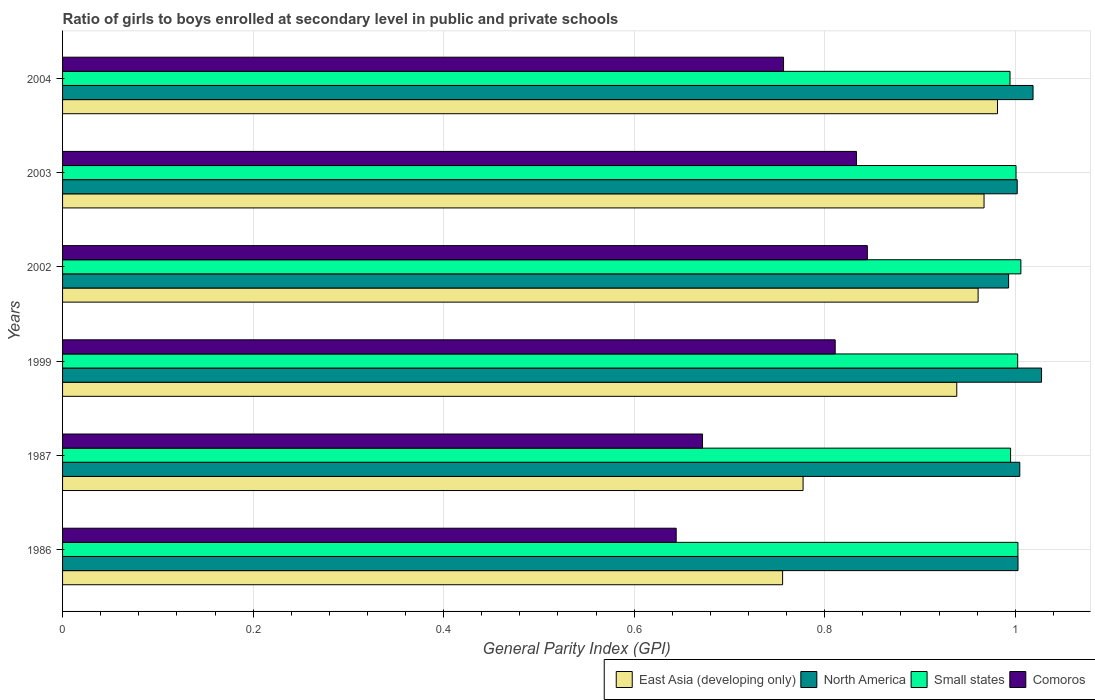How many groups of bars are there?
Offer a terse response. 6. Are the number of bars per tick equal to the number of legend labels?
Offer a terse response. Yes. What is the general parity index in East Asia (developing only) in 1999?
Your answer should be very brief. 0.94. Across all years, what is the maximum general parity index in North America?
Ensure brevity in your answer.  1.03. Across all years, what is the minimum general parity index in North America?
Your response must be concise. 0.99. In which year was the general parity index in Small states maximum?
Make the answer very short. 2002. In which year was the general parity index in Small states minimum?
Offer a terse response. 2004. What is the total general parity index in Comoros in the graph?
Provide a succinct answer. 4.56. What is the difference between the general parity index in East Asia (developing only) in 2002 and that in 2003?
Your answer should be very brief. -0.01. What is the difference between the general parity index in East Asia (developing only) in 1987 and the general parity index in North America in 1999?
Offer a terse response. -0.25. What is the average general parity index in North America per year?
Offer a terse response. 1.01. In the year 1999, what is the difference between the general parity index in Comoros and general parity index in East Asia (developing only)?
Ensure brevity in your answer.  -0.13. In how many years, is the general parity index in Comoros greater than 0.8400000000000001 ?
Provide a succinct answer. 1. What is the ratio of the general parity index in North America in 1986 to that in 1999?
Your answer should be very brief. 0.98. What is the difference between the highest and the second highest general parity index in North America?
Offer a terse response. 0.01. What is the difference between the highest and the lowest general parity index in Comoros?
Provide a short and direct response. 0.2. Is the sum of the general parity index in East Asia (developing only) in 2003 and 2004 greater than the maximum general parity index in Comoros across all years?
Your response must be concise. Yes. What does the 4th bar from the top in 2003 represents?
Make the answer very short. East Asia (developing only). What does the 1st bar from the bottom in 2002 represents?
Your response must be concise. East Asia (developing only). Is it the case that in every year, the sum of the general parity index in Small states and general parity index in North America is greater than the general parity index in East Asia (developing only)?
Give a very brief answer. Yes. How many bars are there?
Your answer should be very brief. 24. What is the difference between two consecutive major ticks on the X-axis?
Ensure brevity in your answer.  0.2. Does the graph contain any zero values?
Offer a terse response. No. What is the title of the graph?
Provide a short and direct response. Ratio of girls to boys enrolled at secondary level in public and private schools. What is the label or title of the X-axis?
Ensure brevity in your answer.  General Parity Index (GPI). What is the General Parity Index (GPI) of East Asia (developing only) in 1986?
Make the answer very short. 0.76. What is the General Parity Index (GPI) of North America in 1986?
Your answer should be very brief. 1. What is the General Parity Index (GPI) of Small states in 1986?
Make the answer very short. 1. What is the General Parity Index (GPI) of Comoros in 1986?
Your response must be concise. 0.64. What is the General Parity Index (GPI) of East Asia (developing only) in 1987?
Keep it short and to the point. 0.78. What is the General Parity Index (GPI) of North America in 1987?
Keep it short and to the point. 1. What is the General Parity Index (GPI) of Small states in 1987?
Offer a very short reply. 1. What is the General Parity Index (GPI) in Comoros in 1987?
Make the answer very short. 0.67. What is the General Parity Index (GPI) in East Asia (developing only) in 1999?
Keep it short and to the point. 0.94. What is the General Parity Index (GPI) in North America in 1999?
Offer a very short reply. 1.03. What is the General Parity Index (GPI) in Small states in 1999?
Provide a succinct answer. 1. What is the General Parity Index (GPI) of Comoros in 1999?
Offer a very short reply. 0.81. What is the General Parity Index (GPI) in East Asia (developing only) in 2002?
Offer a very short reply. 0.96. What is the General Parity Index (GPI) in North America in 2002?
Provide a short and direct response. 0.99. What is the General Parity Index (GPI) in Small states in 2002?
Give a very brief answer. 1.01. What is the General Parity Index (GPI) of Comoros in 2002?
Provide a succinct answer. 0.84. What is the General Parity Index (GPI) of East Asia (developing only) in 2003?
Offer a very short reply. 0.97. What is the General Parity Index (GPI) in North America in 2003?
Your response must be concise. 1. What is the General Parity Index (GPI) of Small states in 2003?
Provide a short and direct response. 1. What is the General Parity Index (GPI) in Comoros in 2003?
Provide a succinct answer. 0.83. What is the General Parity Index (GPI) in East Asia (developing only) in 2004?
Offer a very short reply. 0.98. What is the General Parity Index (GPI) in North America in 2004?
Offer a very short reply. 1.02. What is the General Parity Index (GPI) of Small states in 2004?
Ensure brevity in your answer.  0.99. What is the General Parity Index (GPI) in Comoros in 2004?
Provide a short and direct response. 0.76. Across all years, what is the maximum General Parity Index (GPI) in East Asia (developing only)?
Your answer should be compact. 0.98. Across all years, what is the maximum General Parity Index (GPI) in North America?
Give a very brief answer. 1.03. Across all years, what is the maximum General Parity Index (GPI) in Small states?
Keep it short and to the point. 1.01. Across all years, what is the maximum General Parity Index (GPI) in Comoros?
Your answer should be compact. 0.84. Across all years, what is the minimum General Parity Index (GPI) in East Asia (developing only)?
Provide a succinct answer. 0.76. Across all years, what is the minimum General Parity Index (GPI) of North America?
Your answer should be compact. 0.99. Across all years, what is the minimum General Parity Index (GPI) of Small states?
Give a very brief answer. 0.99. Across all years, what is the minimum General Parity Index (GPI) in Comoros?
Make the answer very short. 0.64. What is the total General Parity Index (GPI) of East Asia (developing only) in the graph?
Give a very brief answer. 5.38. What is the total General Parity Index (GPI) in North America in the graph?
Your response must be concise. 6.05. What is the total General Parity Index (GPI) of Small states in the graph?
Your response must be concise. 6. What is the total General Parity Index (GPI) in Comoros in the graph?
Give a very brief answer. 4.56. What is the difference between the General Parity Index (GPI) of East Asia (developing only) in 1986 and that in 1987?
Offer a very short reply. -0.02. What is the difference between the General Parity Index (GPI) in North America in 1986 and that in 1987?
Provide a succinct answer. -0. What is the difference between the General Parity Index (GPI) of Small states in 1986 and that in 1987?
Provide a succinct answer. 0.01. What is the difference between the General Parity Index (GPI) in Comoros in 1986 and that in 1987?
Ensure brevity in your answer.  -0.03. What is the difference between the General Parity Index (GPI) in East Asia (developing only) in 1986 and that in 1999?
Provide a short and direct response. -0.18. What is the difference between the General Parity Index (GPI) of North America in 1986 and that in 1999?
Ensure brevity in your answer.  -0.02. What is the difference between the General Parity Index (GPI) in Small states in 1986 and that in 1999?
Ensure brevity in your answer.  0. What is the difference between the General Parity Index (GPI) of Comoros in 1986 and that in 1999?
Keep it short and to the point. -0.17. What is the difference between the General Parity Index (GPI) in East Asia (developing only) in 1986 and that in 2002?
Your answer should be very brief. -0.21. What is the difference between the General Parity Index (GPI) in North America in 1986 and that in 2002?
Keep it short and to the point. 0.01. What is the difference between the General Parity Index (GPI) of Small states in 1986 and that in 2002?
Give a very brief answer. -0. What is the difference between the General Parity Index (GPI) of Comoros in 1986 and that in 2002?
Your answer should be compact. -0.2. What is the difference between the General Parity Index (GPI) of East Asia (developing only) in 1986 and that in 2003?
Offer a very short reply. -0.21. What is the difference between the General Parity Index (GPI) in North America in 1986 and that in 2003?
Give a very brief answer. 0. What is the difference between the General Parity Index (GPI) in Small states in 1986 and that in 2003?
Provide a succinct answer. 0. What is the difference between the General Parity Index (GPI) in Comoros in 1986 and that in 2003?
Provide a succinct answer. -0.19. What is the difference between the General Parity Index (GPI) in East Asia (developing only) in 1986 and that in 2004?
Keep it short and to the point. -0.23. What is the difference between the General Parity Index (GPI) in North America in 1986 and that in 2004?
Provide a short and direct response. -0.02. What is the difference between the General Parity Index (GPI) of Small states in 1986 and that in 2004?
Offer a terse response. 0.01. What is the difference between the General Parity Index (GPI) of Comoros in 1986 and that in 2004?
Offer a terse response. -0.11. What is the difference between the General Parity Index (GPI) in East Asia (developing only) in 1987 and that in 1999?
Your response must be concise. -0.16. What is the difference between the General Parity Index (GPI) in North America in 1987 and that in 1999?
Make the answer very short. -0.02. What is the difference between the General Parity Index (GPI) in Small states in 1987 and that in 1999?
Provide a short and direct response. -0.01. What is the difference between the General Parity Index (GPI) in Comoros in 1987 and that in 1999?
Provide a short and direct response. -0.14. What is the difference between the General Parity Index (GPI) in East Asia (developing only) in 1987 and that in 2002?
Your answer should be compact. -0.18. What is the difference between the General Parity Index (GPI) of North America in 1987 and that in 2002?
Give a very brief answer. 0.01. What is the difference between the General Parity Index (GPI) of Small states in 1987 and that in 2002?
Your answer should be very brief. -0.01. What is the difference between the General Parity Index (GPI) of Comoros in 1987 and that in 2002?
Offer a very short reply. -0.17. What is the difference between the General Parity Index (GPI) of East Asia (developing only) in 1987 and that in 2003?
Make the answer very short. -0.19. What is the difference between the General Parity Index (GPI) of North America in 1987 and that in 2003?
Keep it short and to the point. 0. What is the difference between the General Parity Index (GPI) in Small states in 1987 and that in 2003?
Your answer should be very brief. -0.01. What is the difference between the General Parity Index (GPI) in Comoros in 1987 and that in 2003?
Your answer should be compact. -0.16. What is the difference between the General Parity Index (GPI) in East Asia (developing only) in 1987 and that in 2004?
Your answer should be compact. -0.2. What is the difference between the General Parity Index (GPI) in North America in 1987 and that in 2004?
Give a very brief answer. -0.01. What is the difference between the General Parity Index (GPI) of Small states in 1987 and that in 2004?
Offer a terse response. 0. What is the difference between the General Parity Index (GPI) in Comoros in 1987 and that in 2004?
Keep it short and to the point. -0.09. What is the difference between the General Parity Index (GPI) of East Asia (developing only) in 1999 and that in 2002?
Provide a short and direct response. -0.02. What is the difference between the General Parity Index (GPI) in North America in 1999 and that in 2002?
Provide a short and direct response. 0.03. What is the difference between the General Parity Index (GPI) of Small states in 1999 and that in 2002?
Keep it short and to the point. -0. What is the difference between the General Parity Index (GPI) of Comoros in 1999 and that in 2002?
Your response must be concise. -0.03. What is the difference between the General Parity Index (GPI) of East Asia (developing only) in 1999 and that in 2003?
Your answer should be compact. -0.03. What is the difference between the General Parity Index (GPI) in North America in 1999 and that in 2003?
Make the answer very short. 0.03. What is the difference between the General Parity Index (GPI) in Small states in 1999 and that in 2003?
Offer a terse response. 0. What is the difference between the General Parity Index (GPI) in Comoros in 1999 and that in 2003?
Keep it short and to the point. -0.02. What is the difference between the General Parity Index (GPI) in East Asia (developing only) in 1999 and that in 2004?
Offer a terse response. -0.04. What is the difference between the General Parity Index (GPI) in North America in 1999 and that in 2004?
Provide a short and direct response. 0.01. What is the difference between the General Parity Index (GPI) in Small states in 1999 and that in 2004?
Provide a short and direct response. 0.01. What is the difference between the General Parity Index (GPI) in Comoros in 1999 and that in 2004?
Your answer should be compact. 0.05. What is the difference between the General Parity Index (GPI) in East Asia (developing only) in 2002 and that in 2003?
Give a very brief answer. -0.01. What is the difference between the General Parity Index (GPI) in North America in 2002 and that in 2003?
Make the answer very short. -0.01. What is the difference between the General Parity Index (GPI) in Small states in 2002 and that in 2003?
Offer a terse response. 0.01. What is the difference between the General Parity Index (GPI) in Comoros in 2002 and that in 2003?
Ensure brevity in your answer.  0.01. What is the difference between the General Parity Index (GPI) of East Asia (developing only) in 2002 and that in 2004?
Provide a short and direct response. -0.02. What is the difference between the General Parity Index (GPI) in North America in 2002 and that in 2004?
Give a very brief answer. -0.03. What is the difference between the General Parity Index (GPI) of Small states in 2002 and that in 2004?
Keep it short and to the point. 0.01. What is the difference between the General Parity Index (GPI) of Comoros in 2002 and that in 2004?
Ensure brevity in your answer.  0.09. What is the difference between the General Parity Index (GPI) of East Asia (developing only) in 2003 and that in 2004?
Make the answer very short. -0.01. What is the difference between the General Parity Index (GPI) of North America in 2003 and that in 2004?
Keep it short and to the point. -0.02. What is the difference between the General Parity Index (GPI) of Small states in 2003 and that in 2004?
Offer a terse response. 0.01. What is the difference between the General Parity Index (GPI) of Comoros in 2003 and that in 2004?
Your answer should be very brief. 0.08. What is the difference between the General Parity Index (GPI) of East Asia (developing only) in 1986 and the General Parity Index (GPI) of North America in 1987?
Give a very brief answer. -0.25. What is the difference between the General Parity Index (GPI) of East Asia (developing only) in 1986 and the General Parity Index (GPI) of Small states in 1987?
Offer a very short reply. -0.24. What is the difference between the General Parity Index (GPI) in East Asia (developing only) in 1986 and the General Parity Index (GPI) in Comoros in 1987?
Ensure brevity in your answer.  0.08. What is the difference between the General Parity Index (GPI) in North America in 1986 and the General Parity Index (GPI) in Small states in 1987?
Make the answer very short. 0.01. What is the difference between the General Parity Index (GPI) of North America in 1986 and the General Parity Index (GPI) of Comoros in 1987?
Provide a succinct answer. 0.33. What is the difference between the General Parity Index (GPI) of Small states in 1986 and the General Parity Index (GPI) of Comoros in 1987?
Ensure brevity in your answer.  0.33. What is the difference between the General Parity Index (GPI) of East Asia (developing only) in 1986 and the General Parity Index (GPI) of North America in 1999?
Your response must be concise. -0.27. What is the difference between the General Parity Index (GPI) of East Asia (developing only) in 1986 and the General Parity Index (GPI) of Small states in 1999?
Make the answer very short. -0.25. What is the difference between the General Parity Index (GPI) of East Asia (developing only) in 1986 and the General Parity Index (GPI) of Comoros in 1999?
Your response must be concise. -0.06. What is the difference between the General Parity Index (GPI) in North America in 1986 and the General Parity Index (GPI) in Comoros in 1999?
Offer a terse response. 0.19. What is the difference between the General Parity Index (GPI) of Small states in 1986 and the General Parity Index (GPI) of Comoros in 1999?
Keep it short and to the point. 0.19. What is the difference between the General Parity Index (GPI) in East Asia (developing only) in 1986 and the General Parity Index (GPI) in North America in 2002?
Keep it short and to the point. -0.24. What is the difference between the General Parity Index (GPI) in East Asia (developing only) in 1986 and the General Parity Index (GPI) in Small states in 2002?
Your answer should be very brief. -0.25. What is the difference between the General Parity Index (GPI) in East Asia (developing only) in 1986 and the General Parity Index (GPI) in Comoros in 2002?
Your answer should be compact. -0.09. What is the difference between the General Parity Index (GPI) in North America in 1986 and the General Parity Index (GPI) in Small states in 2002?
Provide a succinct answer. -0. What is the difference between the General Parity Index (GPI) of North America in 1986 and the General Parity Index (GPI) of Comoros in 2002?
Your answer should be compact. 0.16. What is the difference between the General Parity Index (GPI) in Small states in 1986 and the General Parity Index (GPI) in Comoros in 2002?
Your response must be concise. 0.16. What is the difference between the General Parity Index (GPI) of East Asia (developing only) in 1986 and the General Parity Index (GPI) of North America in 2003?
Offer a very short reply. -0.25. What is the difference between the General Parity Index (GPI) of East Asia (developing only) in 1986 and the General Parity Index (GPI) of Small states in 2003?
Keep it short and to the point. -0.24. What is the difference between the General Parity Index (GPI) in East Asia (developing only) in 1986 and the General Parity Index (GPI) in Comoros in 2003?
Your response must be concise. -0.08. What is the difference between the General Parity Index (GPI) in North America in 1986 and the General Parity Index (GPI) in Small states in 2003?
Provide a succinct answer. 0. What is the difference between the General Parity Index (GPI) in North America in 1986 and the General Parity Index (GPI) in Comoros in 2003?
Make the answer very short. 0.17. What is the difference between the General Parity Index (GPI) in Small states in 1986 and the General Parity Index (GPI) in Comoros in 2003?
Your answer should be compact. 0.17. What is the difference between the General Parity Index (GPI) of East Asia (developing only) in 1986 and the General Parity Index (GPI) of North America in 2004?
Your answer should be compact. -0.26. What is the difference between the General Parity Index (GPI) of East Asia (developing only) in 1986 and the General Parity Index (GPI) of Small states in 2004?
Your answer should be very brief. -0.24. What is the difference between the General Parity Index (GPI) of East Asia (developing only) in 1986 and the General Parity Index (GPI) of Comoros in 2004?
Ensure brevity in your answer.  -0. What is the difference between the General Parity Index (GPI) of North America in 1986 and the General Parity Index (GPI) of Small states in 2004?
Provide a short and direct response. 0.01. What is the difference between the General Parity Index (GPI) of North America in 1986 and the General Parity Index (GPI) of Comoros in 2004?
Your response must be concise. 0.25. What is the difference between the General Parity Index (GPI) of Small states in 1986 and the General Parity Index (GPI) of Comoros in 2004?
Make the answer very short. 0.25. What is the difference between the General Parity Index (GPI) in East Asia (developing only) in 1987 and the General Parity Index (GPI) in North America in 1999?
Offer a very short reply. -0.25. What is the difference between the General Parity Index (GPI) in East Asia (developing only) in 1987 and the General Parity Index (GPI) in Small states in 1999?
Offer a very short reply. -0.23. What is the difference between the General Parity Index (GPI) of East Asia (developing only) in 1987 and the General Parity Index (GPI) of Comoros in 1999?
Give a very brief answer. -0.03. What is the difference between the General Parity Index (GPI) of North America in 1987 and the General Parity Index (GPI) of Small states in 1999?
Provide a succinct answer. 0. What is the difference between the General Parity Index (GPI) of North America in 1987 and the General Parity Index (GPI) of Comoros in 1999?
Make the answer very short. 0.19. What is the difference between the General Parity Index (GPI) in Small states in 1987 and the General Parity Index (GPI) in Comoros in 1999?
Provide a short and direct response. 0.18. What is the difference between the General Parity Index (GPI) in East Asia (developing only) in 1987 and the General Parity Index (GPI) in North America in 2002?
Offer a terse response. -0.22. What is the difference between the General Parity Index (GPI) in East Asia (developing only) in 1987 and the General Parity Index (GPI) in Small states in 2002?
Provide a short and direct response. -0.23. What is the difference between the General Parity Index (GPI) of East Asia (developing only) in 1987 and the General Parity Index (GPI) of Comoros in 2002?
Offer a terse response. -0.07. What is the difference between the General Parity Index (GPI) of North America in 1987 and the General Parity Index (GPI) of Small states in 2002?
Offer a terse response. -0. What is the difference between the General Parity Index (GPI) of North America in 1987 and the General Parity Index (GPI) of Comoros in 2002?
Your answer should be very brief. 0.16. What is the difference between the General Parity Index (GPI) in Small states in 1987 and the General Parity Index (GPI) in Comoros in 2002?
Offer a terse response. 0.15. What is the difference between the General Parity Index (GPI) of East Asia (developing only) in 1987 and the General Parity Index (GPI) of North America in 2003?
Your answer should be very brief. -0.22. What is the difference between the General Parity Index (GPI) of East Asia (developing only) in 1987 and the General Parity Index (GPI) of Small states in 2003?
Your response must be concise. -0.22. What is the difference between the General Parity Index (GPI) of East Asia (developing only) in 1987 and the General Parity Index (GPI) of Comoros in 2003?
Make the answer very short. -0.06. What is the difference between the General Parity Index (GPI) of North America in 1987 and the General Parity Index (GPI) of Small states in 2003?
Keep it short and to the point. 0. What is the difference between the General Parity Index (GPI) of North America in 1987 and the General Parity Index (GPI) of Comoros in 2003?
Offer a very short reply. 0.17. What is the difference between the General Parity Index (GPI) of Small states in 1987 and the General Parity Index (GPI) of Comoros in 2003?
Offer a terse response. 0.16. What is the difference between the General Parity Index (GPI) of East Asia (developing only) in 1987 and the General Parity Index (GPI) of North America in 2004?
Give a very brief answer. -0.24. What is the difference between the General Parity Index (GPI) in East Asia (developing only) in 1987 and the General Parity Index (GPI) in Small states in 2004?
Provide a short and direct response. -0.22. What is the difference between the General Parity Index (GPI) in East Asia (developing only) in 1987 and the General Parity Index (GPI) in Comoros in 2004?
Your answer should be compact. 0.02. What is the difference between the General Parity Index (GPI) of North America in 1987 and the General Parity Index (GPI) of Small states in 2004?
Provide a succinct answer. 0.01. What is the difference between the General Parity Index (GPI) in North America in 1987 and the General Parity Index (GPI) in Comoros in 2004?
Keep it short and to the point. 0.25. What is the difference between the General Parity Index (GPI) of Small states in 1987 and the General Parity Index (GPI) of Comoros in 2004?
Provide a short and direct response. 0.24. What is the difference between the General Parity Index (GPI) in East Asia (developing only) in 1999 and the General Parity Index (GPI) in North America in 2002?
Ensure brevity in your answer.  -0.05. What is the difference between the General Parity Index (GPI) in East Asia (developing only) in 1999 and the General Parity Index (GPI) in Small states in 2002?
Provide a succinct answer. -0.07. What is the difference between the General Parity Index (GPI) in East Asia (developing only) in 1999 and the General Parity Index (GPI) in Comoros in 2002?
Your answer should be very brief. 0.09. What is the difference between the General Parity Index (GPI) in North America in 1999 and the General Parity Index (GPI) in Small states in 2002?
Provide a succinct answer. 0.02. What is the difference between the General Parity Index (GPI) of North America in 1999 and the General Parity Index (GPI) of Comoros in 2002?
Your answer should be compact. 0.18. What is the difference between the General Parity Index (GPI) in Small states in 1999 and the General Parity Index (GPI) in Comoros in 2002?
Provide a short and direct response. 0.16. What is the difference between the General Parity Index (GPI) of East Asia (developing only) in 1999 and the General Parity Index (GPI) of North America in 2003?
Make the answer very short. -0.06. What is the difference between the General Parity Index (GPI) in East Asia (developing only) in 1999 and the General Parity Index (GPI) in Small states in 2003?
Provide a succinct answer. -0.06. What is the difference between the General Parity Index (GPI) of East Asia (developing only) in 1999 and the General Parity Index (GPI) of Comoros in 2003?
Provide a short and direct response. 0.11. What is the difference between the General Parity Index (GPI) in North America in 1999 and the General Parity Index (GPI) in Small states in 2003?
Your answer should be compact. 0.03. What is the difference between the General Parity Index (GPI) in North America in 1999 and the General Parity Index (GPI) in Comoros in 2003?
Your response must be concise. 0.19. What is the difference between the General Parity Index (GPI) in Small states in 1999 and the General Parity Index (GPI) in Comoros in 2003?
Your answer should be compact. 0.17. What is the difference between the General Parity Index (GPI) in East Asia (developing only) in 1999 and the General Parity Index (GPI) in North America in 2004?
Ensure brevity in your answer.  -0.08. What is the difference between the General Parity Index (GPI) in East Asia (developing only) in 1999 and the General Parity Index (GPI) in Small states in 2004?
Ensure brevity in your answer.  -0.06. What is the difference between the General Parity Index (GPI) of East Asia (developing only) in 1999 and the General Parity Index (GPI) of Comoros in 2004?
Your response must be concise. 0.18. What is the difference between the General Parity Index (GPI) in North America in 1999 and the General Parity Index (GPI) in Small states in 2004?
Your answer should be very brief. 0.03. What is the difference between the General Parity Index (GPI) in North America in 1999 and the General Parity Index (GPI) in Comoros in 2004?
Ensure brevity in your answer.  0.27. What is the difference between the General Parity Index (GPI) in Small states in 1999 and the General Parity Index (GPI) in Comoros in 2004?
Keep it short and to the point. 0.25. What is the difference between the General Parity Index (GPI) in East Asia (developing only) in 2002 and the General Parity Index (GPI) in North America in 2003?
Your answer should be compact. -0.04. What is the difference between the General Parity Index (GPI) in East Asia (developing only) in 2002 and the General Parity Index (GPI) in Small states in 2003?
Provide a succinct answer. -0.04. What is the difference between the General Parity Index (GPI) in East Asia (developing only) in 2002 and the General Parity Index (GPI) in Comoros in 2003?
Give a very brief answer. 0.13. What is the difference between the General Parity Index (GPI) in North America in 2002 and the General Parity Index (GPI) in Small states in 2003?
Your answer should be very brief. -0.01. What is the difference between the General Parity Index (GPI) in North America in 2002 and the General Parity Index (GPI) in Comoros in 2003?
Offer a terse response. 0.16. What is the difference between the General Parity Index (GPI) of Small states in 2002 and the General Parity Index (GPI) of Comoros in 2003?
Your answer should be very brief. 0.17. What is the difference between the General Parity Index (GPI) in East Asia (developing only) in 2002 and the General Parity Index (GPI) in North America in 2004?
Keep it short and to the point. -0.06. What is the difference between the General Parity Index (GPI) in East Asia (developing only) in 2002 and the General Parity Index (GPI) in Small states in 2004?
Offer a terse response. -0.03. What is the difference between the General Parity Index (GPI) of East Asia (developing only) in 2002 and the General Parity Index (GPI) of Comoros in 2004?
Provide a succinct answer. 0.2. What is the difference between the General Parity Index (GPI) in North America in 2002 and the General Parity Index (GPI) in Small states in 2004?
Provide a short and direct response. -0. What is the difference between the General Parity Index (GPI) of North America in 2002 and the General Parity Index (GPI) of Comoros in 2004?
Give a very brief answer. 0.24. What is the difference between the General Parity Index (GPI) in Small states in 2002 and the General Parity Index (GPI) in Comoros in 2004?
Provide a short and direct response. 0.25. What is the difference between the General Parity Index (GPI) of East Asia (developing only) in 2003 and the General Parity Index (GPI) of North America in 2004?
Ensure brevity in your answer.  -0.05. What is the difference between the General Parity Index (GPI) in East Asia (developing only) in 2003 and the General Parity Index (GPI) in Small states in 2004?
Your answer should be very brief. -0.03. What is the difference between the General Parity Index (GPI) in East Asia (developing only) in 2003 and the General Parity Index (GPI) in Comoros in 2004?
Ensure brevity in your answer.  0.21. What is the difference between the General Parity Index (GPI) in North America in 2003 and the General Parity Index (GPI) in Small states in 2004?
Make the answer very short. 0.01. What is the difference between the General Parity Index (GPI) of North America in 2003 and the General Parity Index (GPI) of Comoros in 2004?
Provide a succinct answer. 0.25. What is the difference between the General Parity Index (GPI) in Small states in 2003 and the General Parity Index (GPI) in Comoros in 2004?
Offer a terse response. 0.24. What is the average General Parity Index (GPI) of East Asia (developing only) per year?
Offer a very short reply. 0.9. What is the average General Parity Index (GPI) in Comoros per year?
Your response must be concise. 0.76. In the year 1986, what is the difference between the General Parity Index (GPI) of East Asia (developing only) and General Parity Index (GPI) of North America?
Provide a succinct answer. -0.25. In the year 1986, what is the difference between the General Parity Index (GPI) of East Asia (developing only) and General Parity Index (GPI) of Small states?
Your answer should be compact. -0.25. In the year 1986, what is the difference between the General Parity Index (GPI) of East Asia (developing only) and General Parity Index (GPI) of Comoros?
Offer a very short reply. 0.11. In the year 1986, what is the difference between the General Parity Index (GPI) of North America and General Parity Index (GPI) of Comoros?
Your answer should be compact. 0.36. In the year 1986, what is the difference between the General Parity Index (GPI) in Small states and General Parity Index (GPI) in Comoros?
Your answer should be compact. 0.36. In the year 1987, what is the difference between the General Parity Index (GPI) of East Asia (developing only) and General Parity Index (GPI) of North America?
Offer a terse response. -0.23. In the year 1987, what is the difference between the General Parity Index (GPI) of East Asia (developing only) and General Parity Index (GPI) of Small states?
Keep it short and to the point. -0.22. In the year 1987, what is the difference between the General Parity Index (GPI) of East Asia (developing only) and General Parity Index (GPI) of Comoros?
Provide a short and direct response. 0.11. In the year 1987, what is the difference between the General Parity Index (GPI) in North America and General Parity Index (GPI) in Small states?
Make the answer very short. 0.01. In the year 1987, what is the difference between the General Parity Index (GPI) of North America and General Parity Index (GPI) of Comoros?
Your answer should be compact. 0.33. In the year 1987, what is the difference between the General Parity Index (GPI) in Small states and General Parity Index (GPI) in Comoros?
Offer a terse response. 0.32. In the year 1999, what is the difference between the General Parity Index (GPI) of East Asia (developing only) and General Parity Index (GPI) of North America?
Make the answer very short. -0.09. In the year 1999, what is the difference between the General Parity Index (GPI) of East Asia (developing only) and General Parity Index (GPI) of Small states?
Keep it short and to the point. -0.06. In the year 1999, what is the difference between the General Parity Index (GPI) of East Asia (developing only) and General Parity Index (GPI) of Comoros?
Provide a succinct answer. 0.13. In the year 1999, what is the difference between the General Parity Index (GPI) in North America and General Parity Index (GPI) in Small states?
Your answer should be very brief. 0.03. In the year 1999, what is the difference between the General Parity Index (GPI) of North America and General Parity Index (GPI) of Comoros?
Ensure brevity in your answer.  0.22. In the year 1999, what is the difference between the General Parity Index (GPI) in Small states and General Parity Index (GPI) in Comoros?
Ensure brevity in your answer.  0.19. In the year 2002, what is the difference between the General Parity Index (GPI) in East Asia (developing only) and General Parity Index (GPI) in North America?
Your answer should be very brief. -0.03. In the year 2002, what is the difference between the General Parity Index (GPI) of East Asia (developing only) and General Parity Index (GPI) of Small states?
Make the answer very short. -0.04. In the year 2002, what is the difference between the General Parity Index (GPI) in East Asia (developing only) and General Parity Index (GPI) in Comoros?
Provide a succinct answer. 0.12. In the year 2002, what is the difference between the General Parity Index (GPI) of North America and General Parity Index (GPI) of Small states?
Provide a succinct answer. -0.01. In the year 2002, what is the difference between the General Parity Index (GPI) in North America and General Parity Index (GPI) in Comoros?
Give a very brief answer. 0.15. In the year 2002, what is the difference between the General Parity Index (GPI) of Small states and General Parity Index (GPI) of Comoros?
Ensure brevity in your answer.  0.16. In the year 2003, what is the difference between the General Parity Index (GPI) of East Asia (developing only) and General Parity Index (GPI) of North America?
Provide a short and direct response. -0.03. In the year 2003, what is the difference between the General Parity Index (GPI) in East Asia (developing only) and General Parity Index (GPI) in Small states?
Your answer should be compact. -0.03. In the year 2003, what is the difference between the General Parity Index (GPI) of East Asia (developing only) and General Parity Index (GPI) of Comoros?
Offer a very short reply. 0.13. In the year 2003, what is the difference between the General Parity Index (GPI) of North America and General Parity Index (GPI) of Small states?
Provide a short and direct response. 0. In the year 2003, what is the difference between the General Parity Index (GPI) of North America and General Parity Index (GPI) of Comoros?
Your answer should be compact. 0.17. In the year 2003, what is the difference between the General Parity Index (GPI) in Small states and General Parity Index (GPI) in Comoros?
Offer a very short reply. 0.17. In the year 2004, what is the difference between the General Parity Index (GPI) of East Asia (developing only) and General Parity Index (GPI) of North America?
Ensure brevity in your answer.  -0.04. In the year 2004, what is the difference between the General Parity Index (GPI) of East Asia (developing only) and General Parity Index (GPI) of Small states?
Your answer should be very brief. -0.01. In the year 2004, what is the difference between the General Parity Index (GPI) of East Asia (developing only) and General Parity Index (GPI) of Comoros?
Give a very brief answer. 0.22. In the year 2004, what is the difference between the General Parity Index (GPI) of North America and General Parity Index (GPI) of Small states?
Ensure brevity in your answer.  0.02. In the year 2004, what is the difference between the General Parity Index (GPI) in North America and General Parity Index (GPI) in Comoros?
Your answer should be very brief. 0.26. In the year 2004, what is the difference between the General Parity Index (GPI) in Small states and General Parity Index (GPI) in Comoros?
Ensure brevity in your answer.  0.24. What is the ratio of the General Parity Index (GPI) in East Asia (developing only) in 1986 to that in 1987?
Your response must be concise. 0.97. What is the ratio of the General Parity Index (GPI) of Small states in 1986 to that in 1987?
Your response must be concise. 1.01. What is the ratio of the General Parity Index (GPI) in Comoros in 1986 to that in 1987?
Your answer should be compact. 0.96. What is the ratio of the General Parity Index (GPI) in East Asia (developing only) in 1986 to that in 1999?
Make the answer very short. 0.81. What is the ratio of the General Parity Index (GPI) of North America in 1986 to that in 1999?
Provide a short and direct response. 0.98. What is the ratio of the General Parity Index (GPI) in Comoros in 1986 to that in 1999?
Ensure brevity in your answer.  0.79. What is the ratio of the General Parity Index (GPI) in East Asia (developing only) in 1986 to that in 2002?
Offer a very short reply. 0.79. What is the ratio of the General Parity Index (GPI) of North America in 1986 to that in 2002?
Offer a terse response. 1.01. What is the ratio of the General Parity Index (GPI) of Small states in 1986 to that in 2002?
Provide a short and direct response. 1. What is the ratio of the General Parity Index (GPI) in Comoros in 1986 to that in 2002?
Your answer should be compact. 0.76. What is the ratio of the General Parity Index (GPI) of East Asia (developing only) in 1986 to that in 2003?
Provide a short and direct response. 0.78. What is the ratio of the General Parity Index (GPI) in North America in 1986 to that in 2003?
Ensure brevity in your answer.  1. What is the ratio of the General Parity Index (GPI) in Small states in 1986 to that in 2003?
Provide a short and direct response. 1. What is the ratio of the General Parity Index (GPI) in Comoros in 1986 to that in 2003?
Provide a succinct answer. 0.77. What is the ratio of the General Parity Index (GPI) in East Asia (developing only) in 1986 to that in 2004?
Make the answer very short. 0.77. What is the ratio of the General Parity Index (GPI) of North America in 1986 to that in 2004?
Your response must be concise. 0.98. What is the ratio of the General Parity Index (GPI) in Small states in 1986 to that in 2004?
Provide a succinct answer. 1.01. What is the ratio of the General Parity Index (GPI) in Comoros in 1986 to that in 2004?
Provide a succinct answer. 0.85. What is the ratio of the General Parity Index (GPI) in East Asia (developing only) in 1987 to that in 1999?
Make the answer very short. 0.83. What is the ratio of the General Parity Index (GPI) of North America in 1987 to that in 1999?
Provide a short and direct response. 0.98. What is the ratio of the General Parity Index (GPI) in Small states in 1987 to that in 1999?
Offer a very short reply. 0.99. What is the ratio of the General Parity Index (GPI) of Comoros in 1987 to that in 1999?
Provide a succinct answer. 0.83. What is the ratio of the General Parity Index (GPI) in East Asia (developing only) in 1987 to that in 2002?
Offer a terse response. 0.81. What is the ratio of the General Parity Index (GPI) of North America in 1987 to that in 2002?
Provide a succinct answer. 1.01. What is the ratio of the General Parity Index (GPI) in Small states in 1987 to that in 2002?
Provide a short and direct response. 0.99. What is the ratio of the General Parity Index (GPI) of Comoros in 1987 to that in 2002?
Your answer should be very brief. 0.8. What is the ratio of the General Parity Index (GPI) of East Asia (developing only) in 1987 to that in 2003?
Ensure brevity in your answer.  0.8. What is the ratio of the General Parity Index (GPI) in North America in 1987 to that in 2003?
Your answer should be very brief. 1. What is the ratio of the General Parity Index (GPI) of Comoros in 1987 to that in 2003?
Give a very brief answer. 0.81. What is the ratio of the General Parity Index (GPI) of East Asia (developing only) in 1987 to that in 2004?
Your answer should be very brief. 0.79. What is the ratio of the General Parity Index (GPI) of North America in 1987 to that in 2004?
Provide a short and direct response. 0.99. What is the ratio of the General Parity Index (GPI) of Comoros in 1987 to that in 2004?
Your answer should be compact. 0.89. What is the ratio of the General Parity Index (GPI) of East Asia (developing only) in 1999 to that in 2002?
Your response must be concise. 0.98. What is the ratio of the General Parity Index (GPI) of North America in 1999 to that in 2002?
Give a very brief answer. 1.03. What is the ratio of the General Parity Index (GPI) of Comoros in 1999 to that in 2002?
Provide a succinct answer. 0.96. What is the ratio of the General Parity Index (GPI) of East Asia (developing only) in 1999 to that in 2003?
Keep it short and to the point. 0.97. What is the ratio of the General Parity Index (GPI) of North America in 1999 to that in 2003?
Provide a succinct answer. 1.03. What is the ratio of the General Parity Index (GPI) in Comoros in 1999 to that in 2003?
Make the answer very short. 0.97. What is the ratio of the General Parity Index (GPI) of East Asia (developing only) in 1999 to that in 2004?
Provide a short and direct response. 0.96. What is the ratio of the General Parity Index (GPI) in North America in 1999 to that in 2004?
Your answer should be very brief. 1.01. What is the ratio of the General Parity Index (GPI) of Small states in 1999 to that in 2004?
Make the answer very short. 1.01. What is the ratio of the General Parity Index (GPI) of Comoros in 1999 to that in 2004?
Offer a terse response. 1.07. What is the ratio of the General Parity Index (GPI) of East Asia (developing only) in 2002 to that in 2003?
Give a very brief answer. 0.99. What is the ratio of the General Parity Index (GPI) of North America in 2002 to that in 2003?
Your response must be concise. 0.99. What is the ratio of the General Parity Index (GPI) in Comoros in 2002 to that in 2003?
Provide a succinct answer. 1.01. What is the ratio of the General Parity Index (GPI) of East Asia (developing only) in 2002 to that in 2004?
Provide a short and direct response. 0.98. What is the ratio of the General Parity Index (GPI) in North America in 2002 to that in 2004?
Provide a succinct answer. 0.97. What is the ratio of the General Parity Index (GPI) in Small states in 2002 to that in 2004?
Give a very brief answer. 1.01. What is the ratio of the General Parity Index (GPI) in Comoros in 2002 to that in 2004?
Offer a terse response. 1.12. What is the ratio of the General Parity Index (GPI) in East Asia (developing only) in 2003 to that in 2004?
Provide a succinct answer. 0.99. What is the ratio of the General Parity Index (GPI) of North America in 2003 to that in 2004?
Your answer should be very brief. 0.98. What is the ratio of the General Parity Index (GPI) of Small states in 2003 to that in 2004?
Provide a short and direct response. 1.01. What is the ratio of the General Parity Index (GPI) of Comoros in 2003 to that in 2004?
Keep it short and to the point. 1.1. What is the difference between the highest and the second highest General Parity Index (GPI) in East Asia (developing only)?
Make the answer very short. 0.01. What is the difference between the highest and the second highest General Parity Index (GPI) in North America?
Ensure brevity in your answer.  0.01. What is the difference between the highest and the second highest General Parity Index (GPI) in Small states?
Your response must be concise. 0. What is the difference between the highest and the second highest General Parity Index (GPI) of Comoros?
Make the answer very short. 0.01. What is the difference between the highest and the lowest General Parity Index (GPI) of East Asia (developing only)?
Ensure brevity in your answer.  0.23. What is the difference between the highest and the lowest General Parity Index (GPI) in North America?
Keep it short and to the point. 0.03. What is the difference between the highest and the lowest General Parity Index (GPI) of Small states?
Give a very brief answer. 0.01. What is the difference between the highest and the lowest General Parity Index (GPI) in Comoros?
Keep it short and to the point. 0.2. 